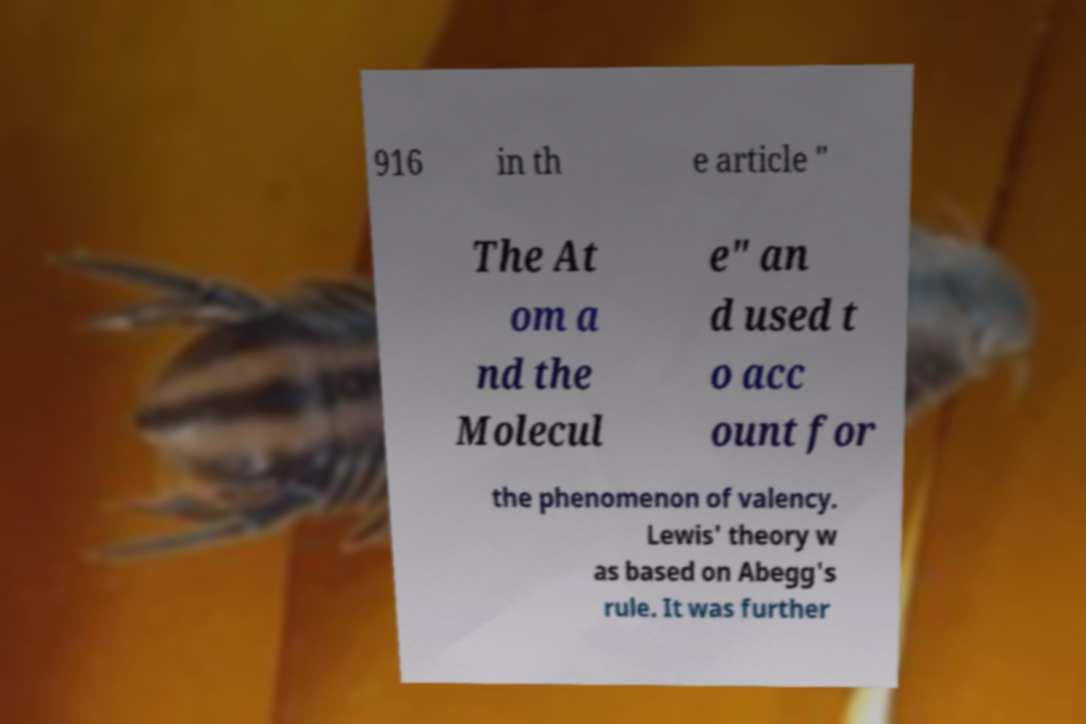There's text embedded in this image that I need extracted. Can you transcribe it verbatim? 916 in th e article " The At om a nd the Molecul e" an d used t o acc ount for the phenomenon of valency. Lewis' theory w as based on Abegg's rule. It was further 